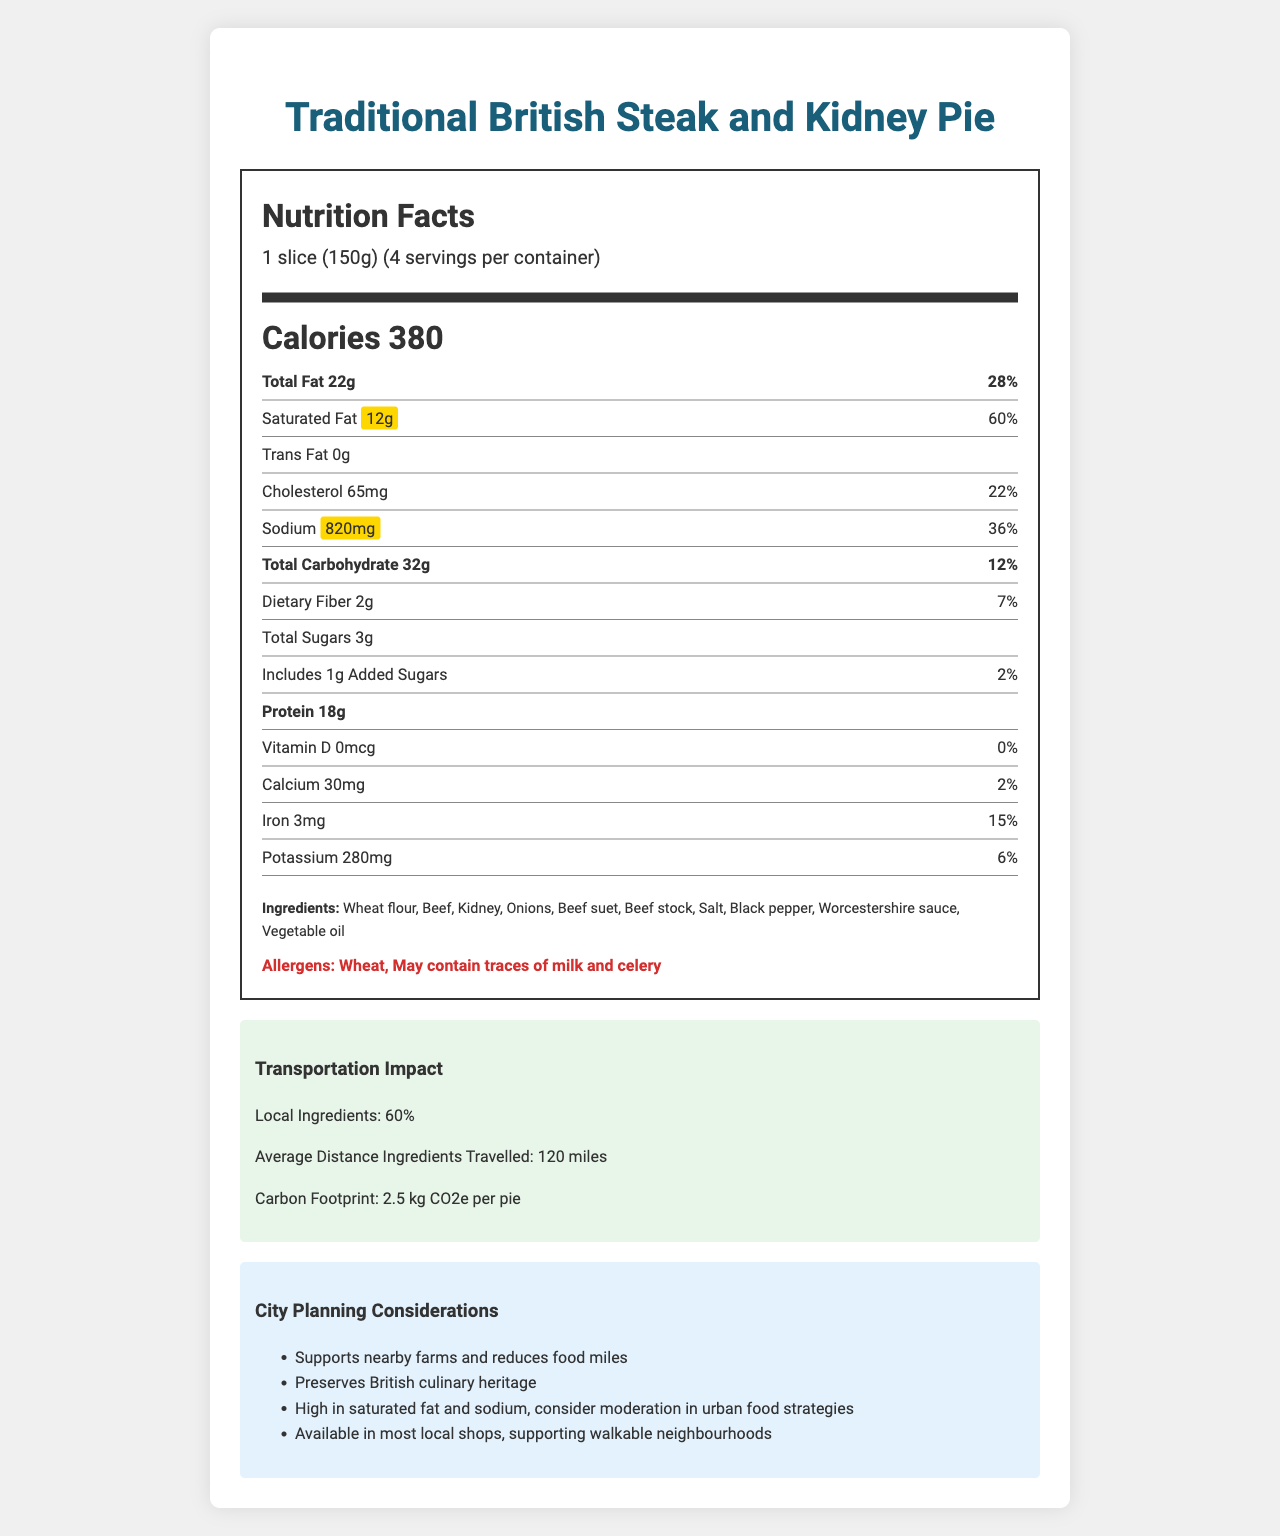what is the serving size for the Traditional British Steak and Kidney Pie? The serving size is mentioned at the top of the nutrition label: "1 slice (150g)".
Answer: 1 slice (150g) how many servings are there per container? It is specified under the serving size: "4 servings per container".
Answer: 4 how much sodium is in one serving? The sodium content per serving is listed under the sodium section: "820mg".
Answer: 820mg what is the percentage of daily value (%DV) for saturated fat per serving? The percent daily value for saturated fat per serving is provided: "60%".
Answer: 60% how much protein is in one serving? The amount of protein per serving is listed under the protein section: "18g".
Answer: 18g What percentage of ingredients are locally sourced? A. 50% B. 60% C. 70% The transportation impact section states that "Local Ingredients: 60%".
Answer: B How many calories are there per serving of Traditional British Steak and Kidney Pie? A. 200 B. 300 C. 380 The calories per serving are stated right below the nutrition header: "Calories 380".
Answer: C Is there any trans fat in the Traditional British Steak and Kidney Pie? The document shows "Trans Fat 0g" indicating there is no trans fat.
Answer: No Does the pie contain any allergens? The allergens section lists: "Wheat, May contain traces of milk and celery".
Answer: Yes Describe the main idea of the document. The document highlights the nutritional information per serving, including high contents of saturated fat and sodium. It also discusses the ingredients, potential allergens, the impact of ingredient transportation, and considerations for city planning such as local food production and public health.
Answer: The document provides the Nutrition Facts Label for a Traditional British Steak and Kidney Pie, detailing the nutritional content, ingredients, allergens, transportation impact, and city planning considerations. where is the product made? The document does not specify the exact location where the product is made.
Answer: Not enough information 